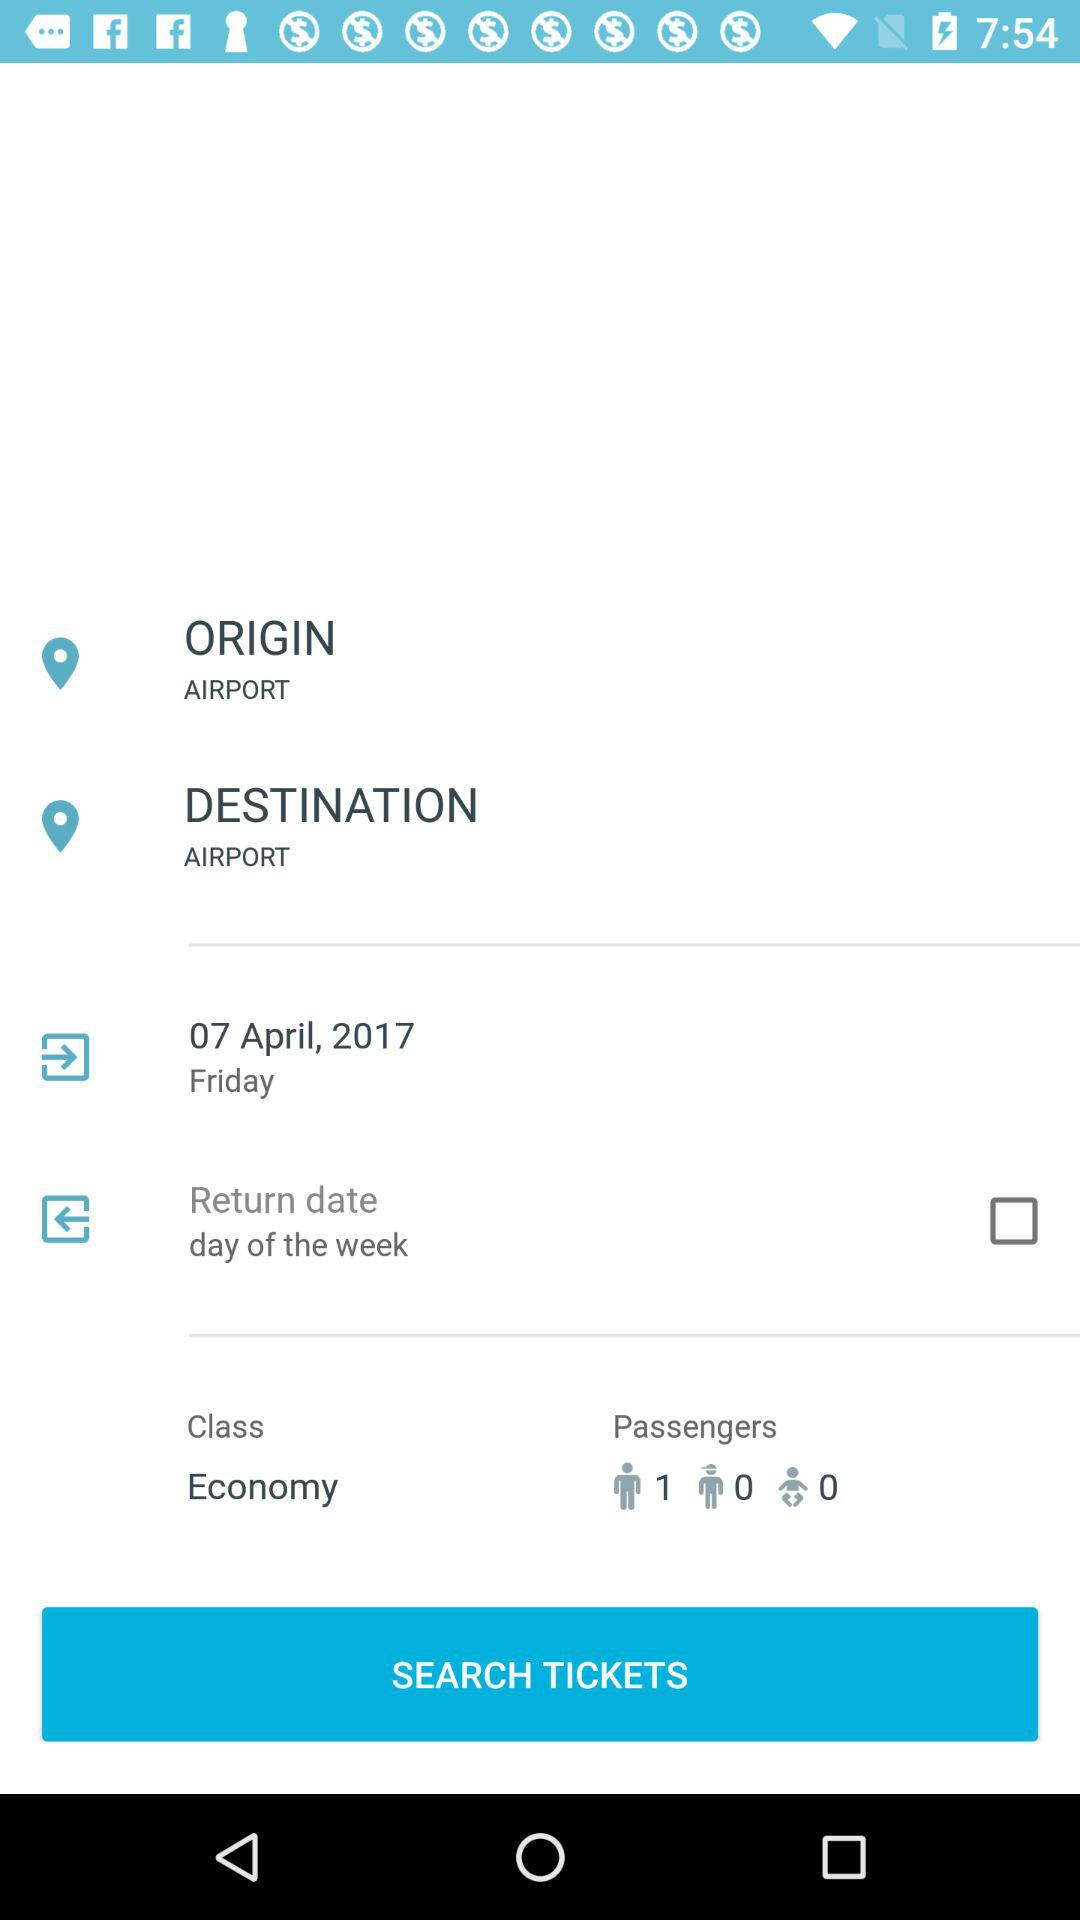How many passengers are there?
Answer the question using a single word or phrase. 1 